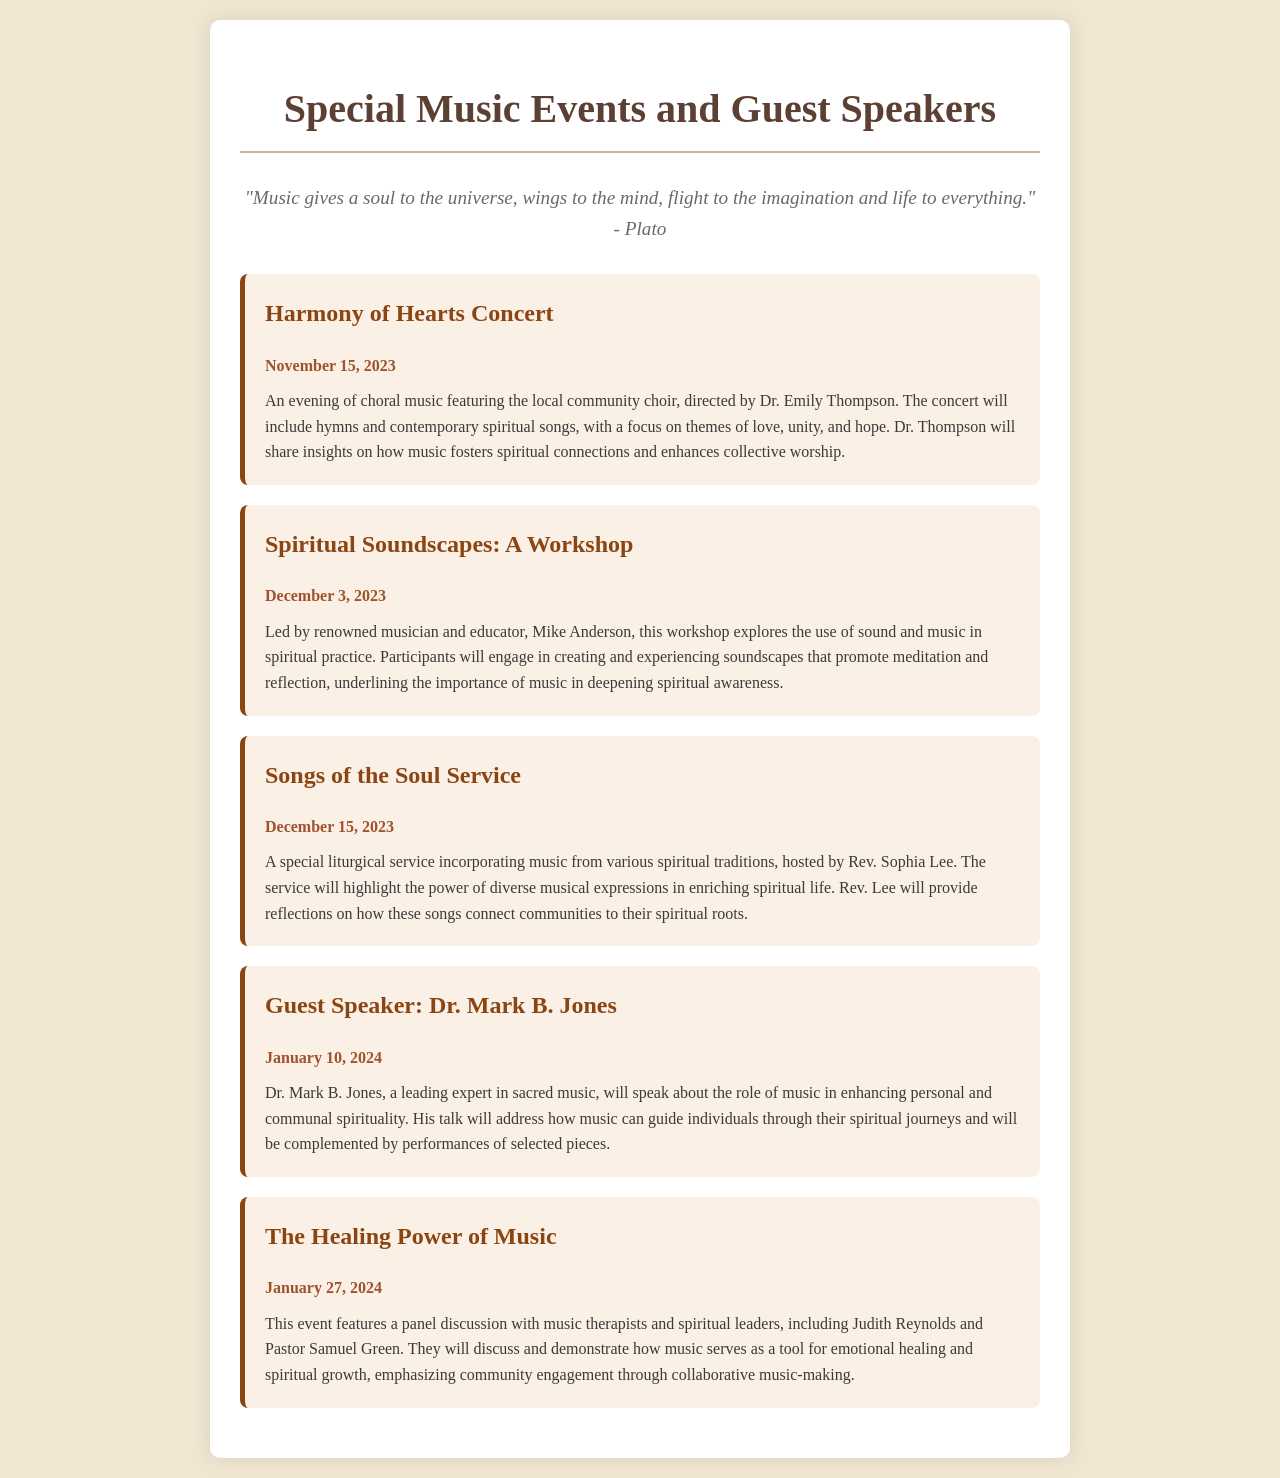What is the date of the Harmony of Hearts Concert? The date of the Harmony of Hearts Concert is provided in the document as November 15, 2023.
Answer: November 15, 2023 Who is directing the Harmony of Hearts Concert? The document states that the concert is directed by Dr. Emily Thompson.
Answer: Dr. Emily Thompson What is the focus theme of the Songs of the Soul Service? The document describes the service as emphasizing the power of diverse musical expressions in enriching spiritual life.
Answer: Diverse musical expressions What will Dr. Mark B. Jones discuss in his talk? The document indicates that he will speak about the role of music in enhancing personal and communal spirituality.
Answer: Role of music in enhancing spirituality When is the workshop led by Mike Anderson? The workshop is scheduled for December 3, 2023, as mentioned in the document.
Answer: December 3, 2023 What type of event is "The Healing Power of Music"? The document categorizes this event as a panel discussion.
Answer: Panel discussion How many special music events are mentioned in the document? By counting the events listed, the document presents a total of five special music events.
Answer: Five What is the main activity during the Spiritual Soundscapes workshop? The document describes the main activity as creating and experiencing soundscapes that promote meditation and reflection.
Answer: Creating and experiencing soundscapes 